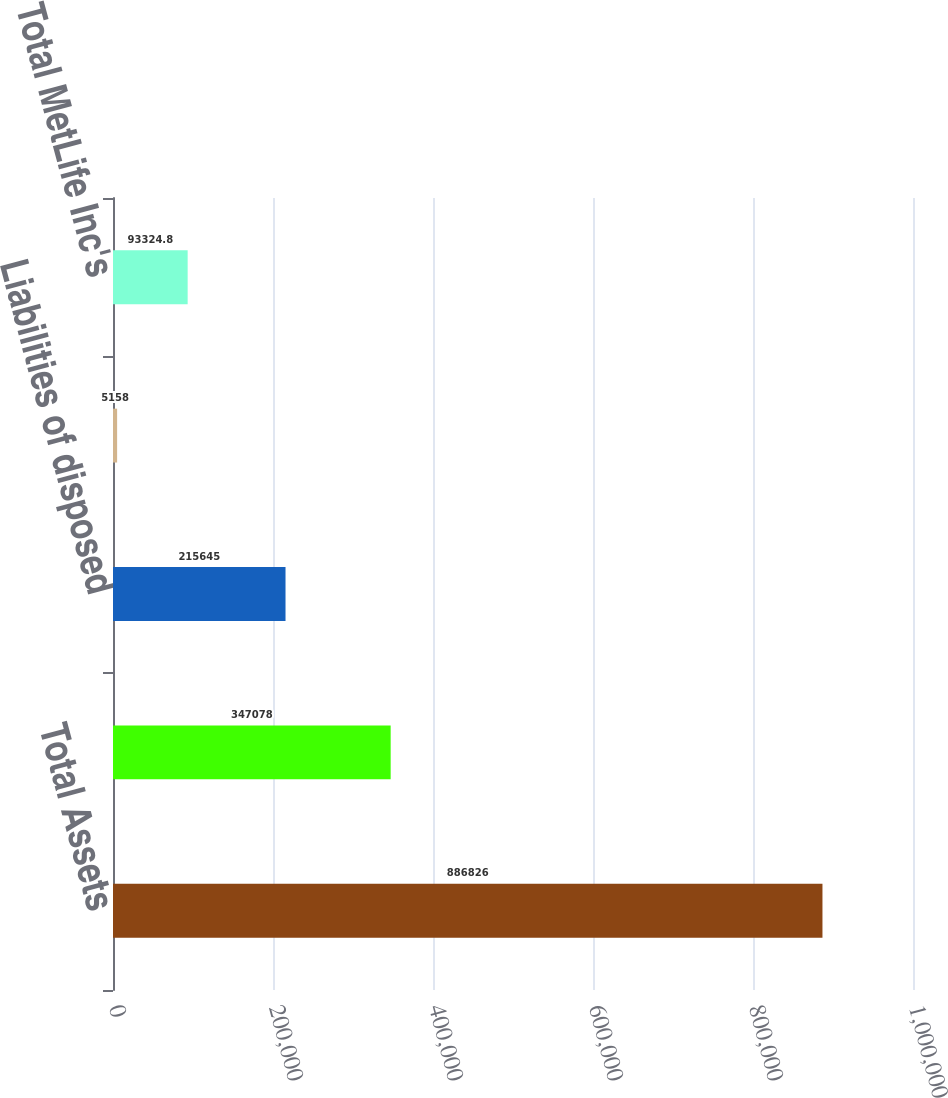Convert chart to OTSL. <chart><loc_0><loc_0><loc_500><loc_500><bar_chart><fcel>Total Assets<fcel>Policyholder liabilities and<fcel>Liabilities of disposed<fcel>Accumulated other<fcel>Total MetLife Inc's<nl><fcel>886826<fcel>347078<fcel>215645<fcel>5158<fcel>93324.8<nl></chart> 